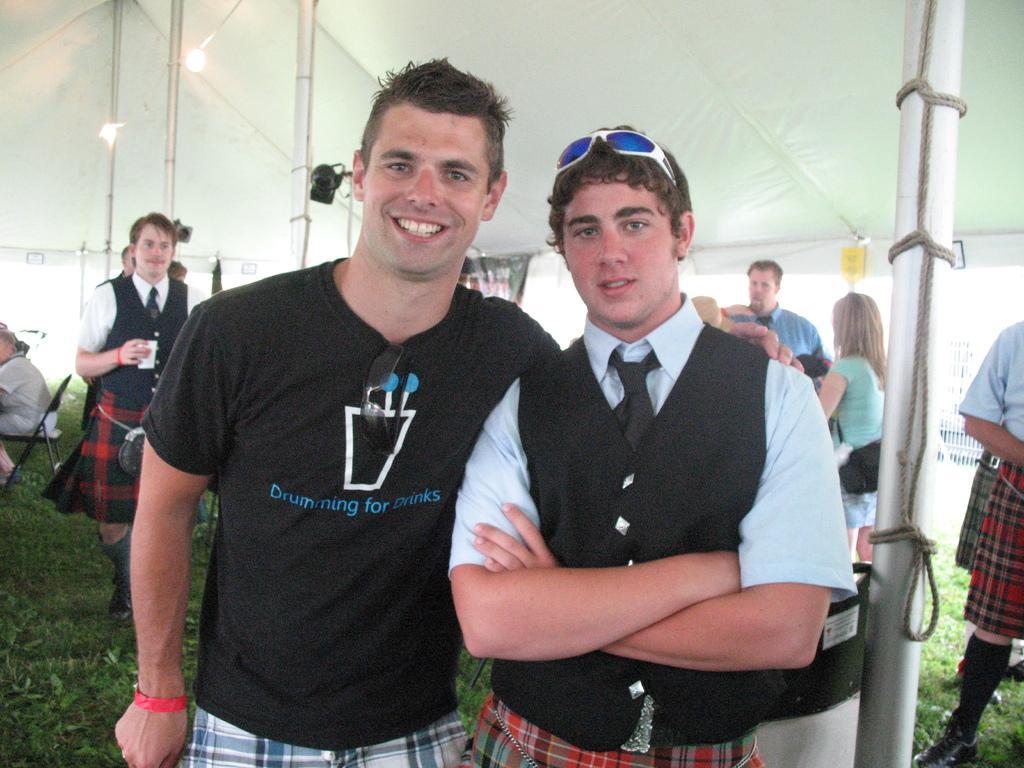Can you describe this image briefly? In this image we can see a few people are standing under a tent. There is a person who is sitting on a chair at the center left most of the image. 